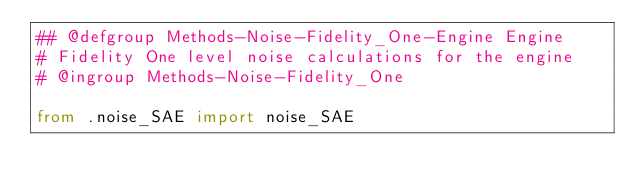<code> <loc_0><loc_0><loc_500><loc_500><_Python_>## @defgroup Methods-Noise-Fidelity_One-Engine Engine
# Fidelity One level noise calculations for the engine
# @ingroup Methods-Noise-Fidelity_One

from .noise_SAE import noise_SAE</code> 